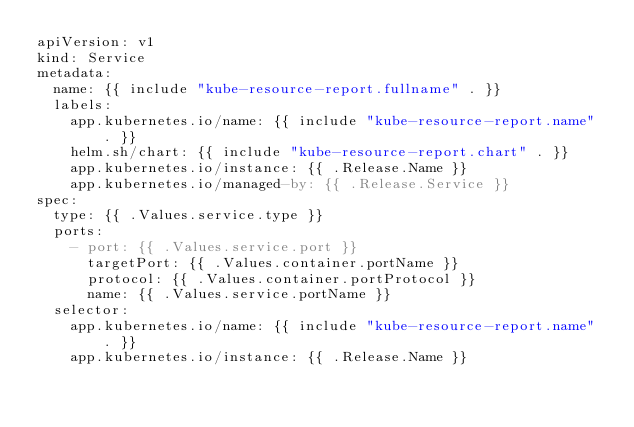Convert code to text. <code><loc_0><loc_0><loc_500><loc_500><_YAML_>apiVersion: v1
kind: Service
metadata:
  name: {{ include "kube-resource-report.fullname" . }}
  labels:
    app.kubernetes.io/name: {{ include "kube-resource-report.name" . }}
    helm.sh/chart: {{ include "kube-resource-report.chart" . }}
    app.kubernetes.io/instance: {{ .Release.Name }}
    app.kubernetes.io/managed-by: {{ .Release.Service }}
spec:
  type: {{ .Values.service.type }}
  ports:
    - port: {{ .Values.service.port }}
      targetPort: {{ .Values.container.portName }}
      protocol: {{ .Values.container.portProtocol }}
      name: {{ .Values.service.portName }}
  selector:
    app.kubernetes.io/name: {{ include "kube-resource-report.name" . }}
    app.kubernetes.io/instance: {{ .Release.Name }}
</code> 